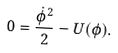<formula> <loc_0><loc_0><loc_500><loc_500>0 = \frac { { \dot { \phi } } ^ { 2 } } { 2 } - U ( \phi ) .</formula> 